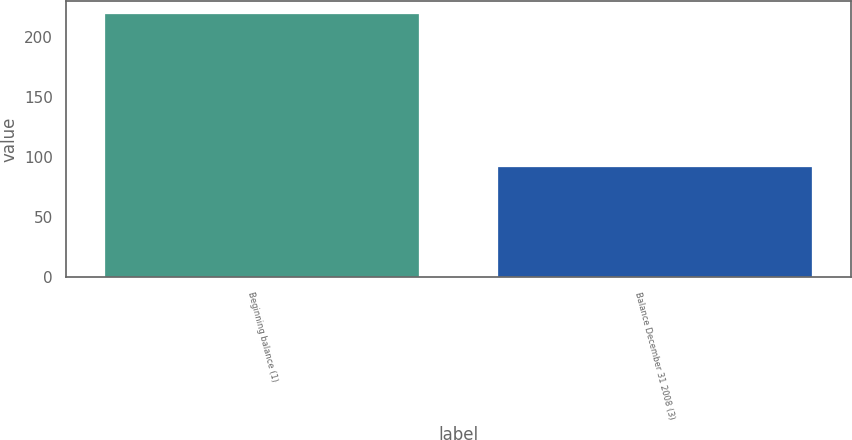Convert chart to OTSL. <chart><loc_0><loc_0><loc_500><loc_500><bar_chart><fcel>Beginning balance (1)<fcel>Balance December 31 2008 (3)<nl><fcel>219<fcel>92<nl></chart> 